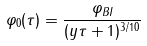Convert formula to latex. <formula><loc_0><loc_0><loc_500><loc_500>\varphi _ { 0 } ( \tau ) = \frac { \varphi _ { B I } } { ( y \tau + 1 ) ^ { 3 / 1 0 } }</formula> 